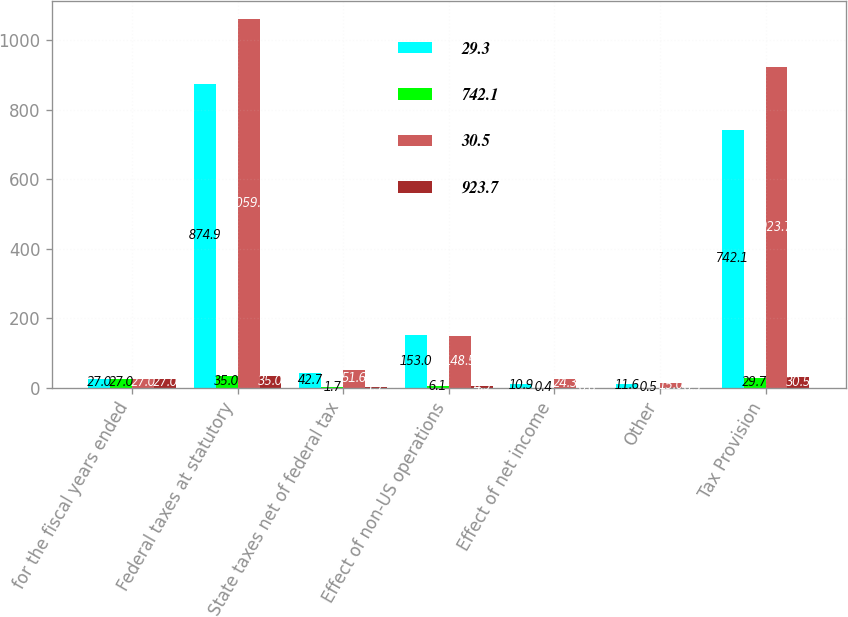Convert chart to OTSL. <chart><loc_0><loc_0><loc_500><loc_500><stacked_bar_chart><ecel><fcel>for the fiscal years ended<fcel>Federal taxes at statutory<fcel>State taxes net of federal tax<fcel>Effect of non-US operations<fcel>Effect of net income<fcel>Other<fcel>Tax Provision<nl><fcel>29.3<fcel>27<fcel>874.9<fcel>42.7<fcel>153<fcel>10.9<fcel>11.6<fcel>742.1<nl><fcel>742.1<fcel>27<fcel>35<fcel>1.7<fcel>6.1<fcel>0.4<fcel>0.5<fcel>29.7<nl><fcel>30.5<fcel>27<fcel>1059.9<fcel>51.6<fcel>148.5<fcel>24.3<fcel>15<fcel>923.7<nl><fcel>923.7<fcel>27<fcel>35<fcel>1.7<fcel>4.9<fcel>0.8<fcel>0.5<fcel>30.5<nl></chart> 